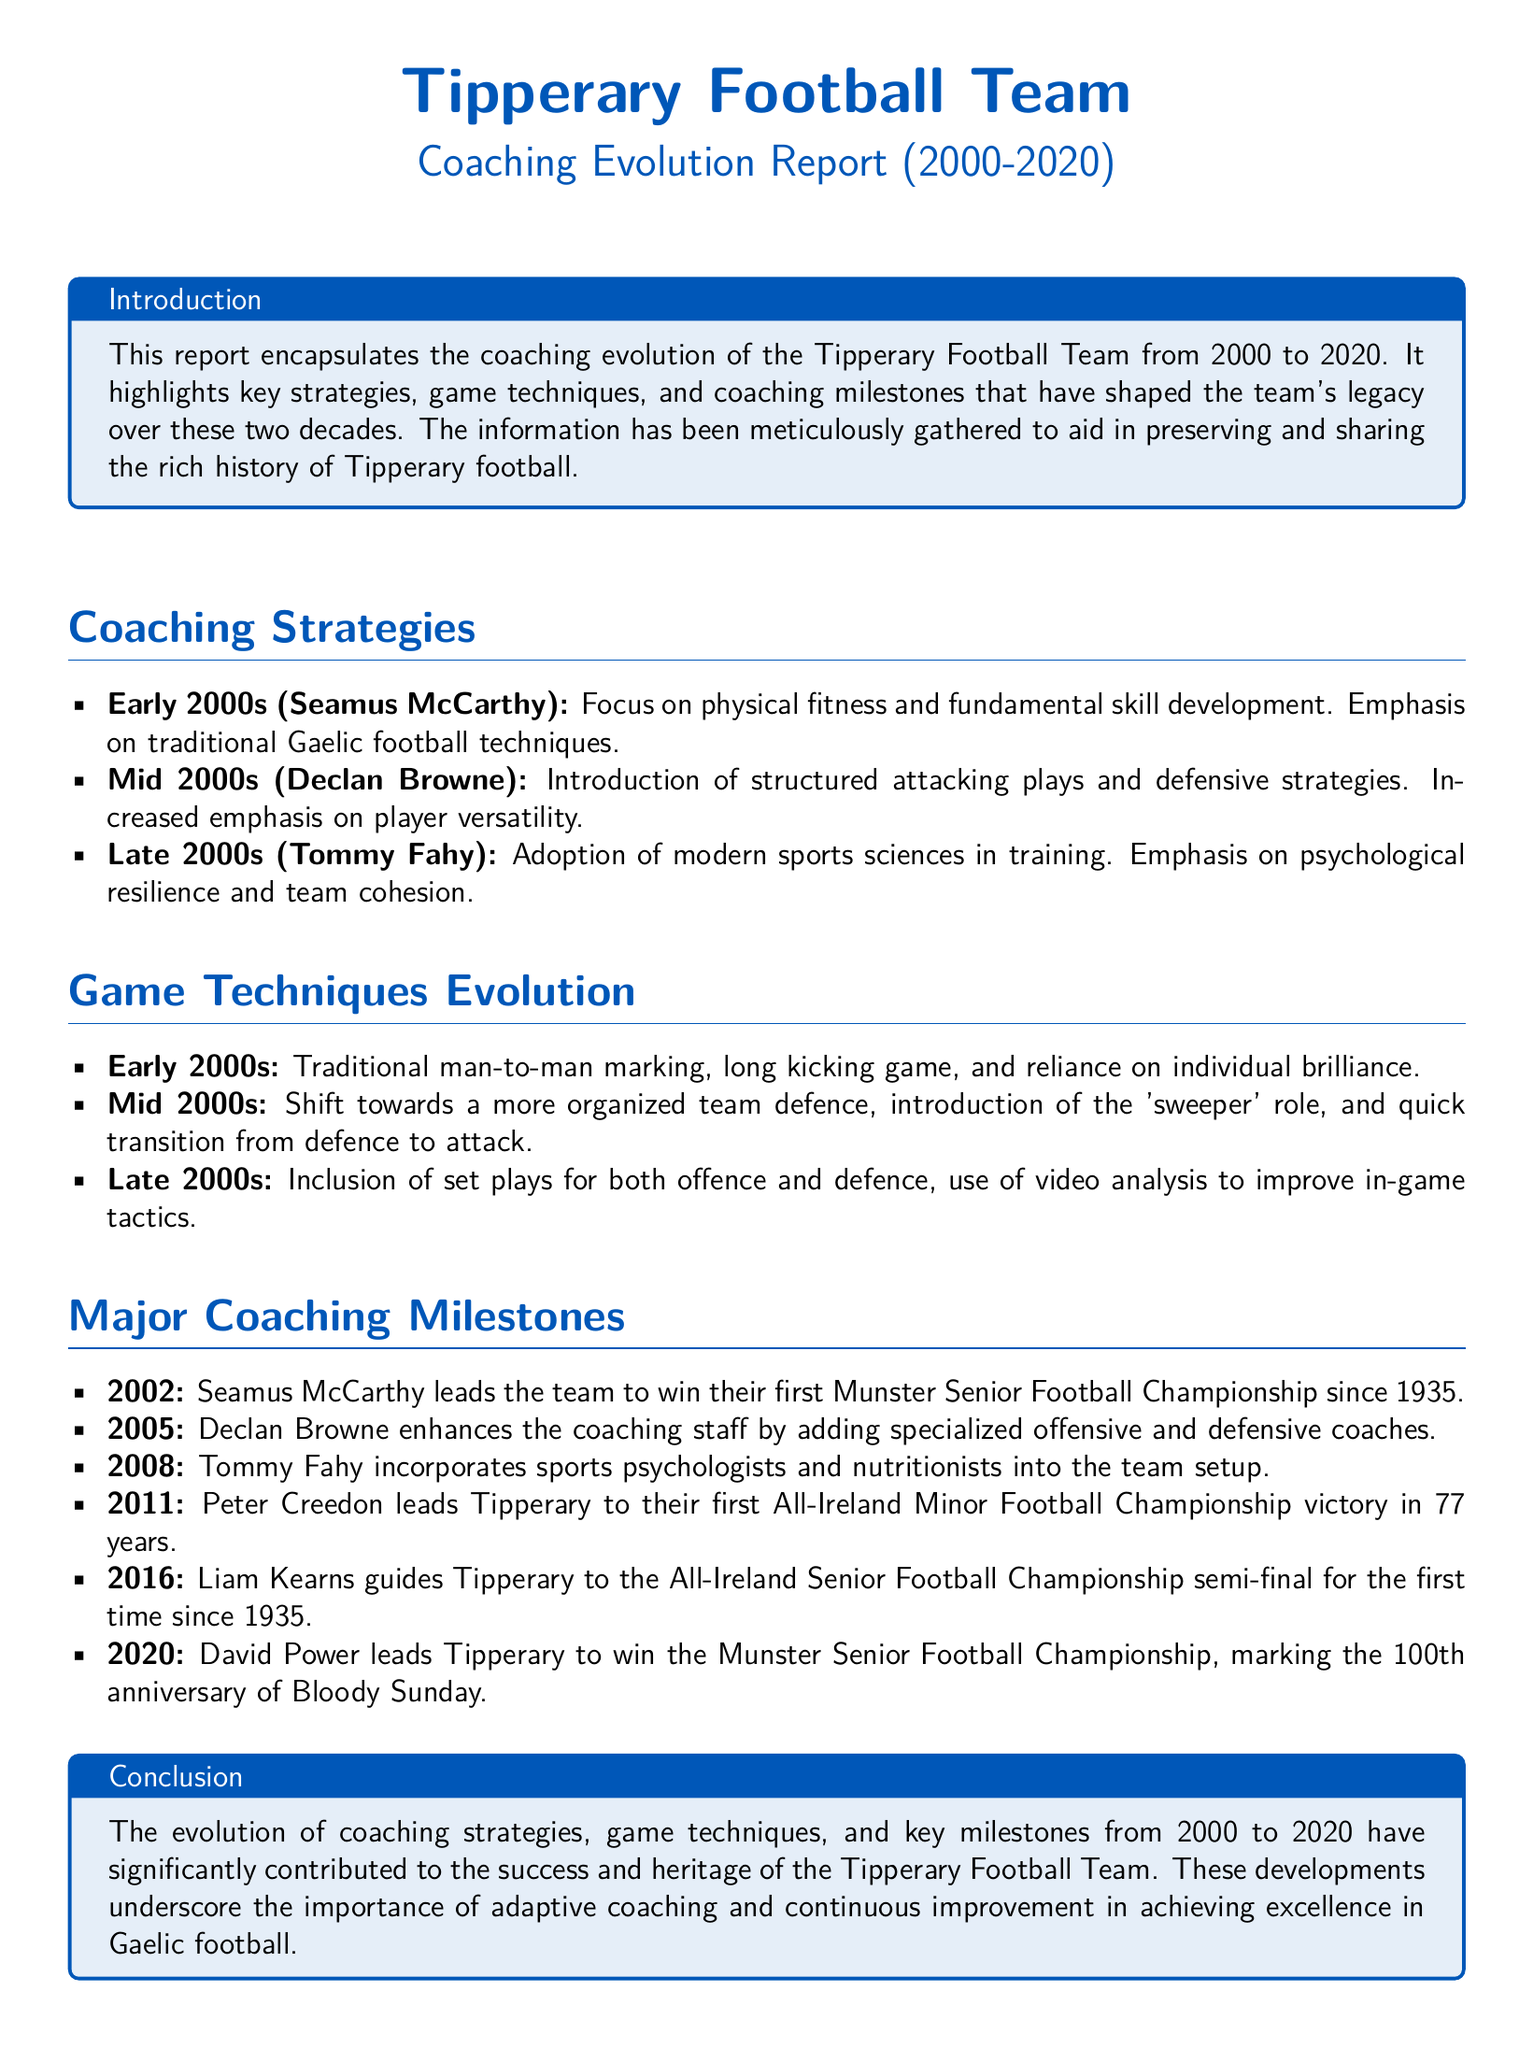What coaching strategy was emphasized in the early 2000s? The early 2000s focused on physical fitness and fundamental skill development, emphasizing traditional Gaelic football techniques.
Answer: physical fitness What year did Tipperary win their first Munster Senior Football Championship after 1935? The milestone year mentioned in the document for winning the Munster Senior Football Championship since 1935 is 2002.
Answer: 2002 Who enhanced the coaching staff in 2005? The document states that Declan Browne enhanced the coaching staff by adding specialized coaches.
Answer: Declan Browne What role was introduced in the mid-2000s to improve defense? The document mentions the introduction of the ‘sweeper’ role as part of organized team defense.
Answer: 'sweeper' Which coach incorporated sports psychologists and nutritionists into the team setup? According to the document, Tommy Fahy was the coach who incorporated sports psychologists and nutritionists.
Answer: Tommy Fahy What significant achievement did Peter Creedon accomplish in 2011? Peter Creedon led Tipperary to their first All-Ireland Minor Football Championship victory in 77 years.
Answer: All-Ireland Minor Football Championship Which year marked David Power's leadership in winning the Munster Senior Football Championship? The document indicates that David Power led Tipperary to win the championship in the year 2020.
Answer: 2020 What was a key focus of game techniques in the late 2000s? In the late 2000s, there was an emphasis on the inclusion of set plays for both offense and defense.
Answer: set plays In what aspect did Tommy Fahy contribute during his coaching period in the late 2000s? The document points out that Tommy Fahy included modern sports sciences in training, emphasizing psychological resilience.
Answer: modern sports sciences 